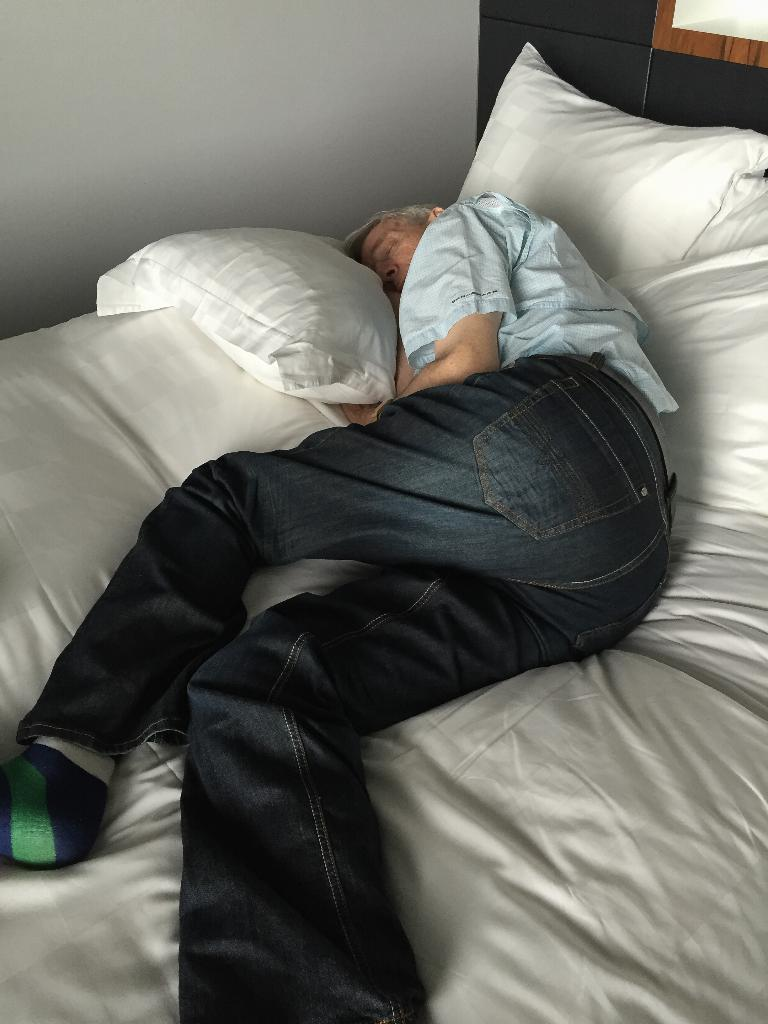Who is present in the image? There is a man in the image. What is the man doing in the image? The man is sleeping on a bed. What can be found on the bed besides the man? There are pillows on the bed. What can be seen in the background of the image? There is a wall visible in the background of the image. What type of wool is being used to make the coast visible in the image? There is no wool or coast present in the image; it features a man sleeping on a bed with pillows and a wall in the background. 